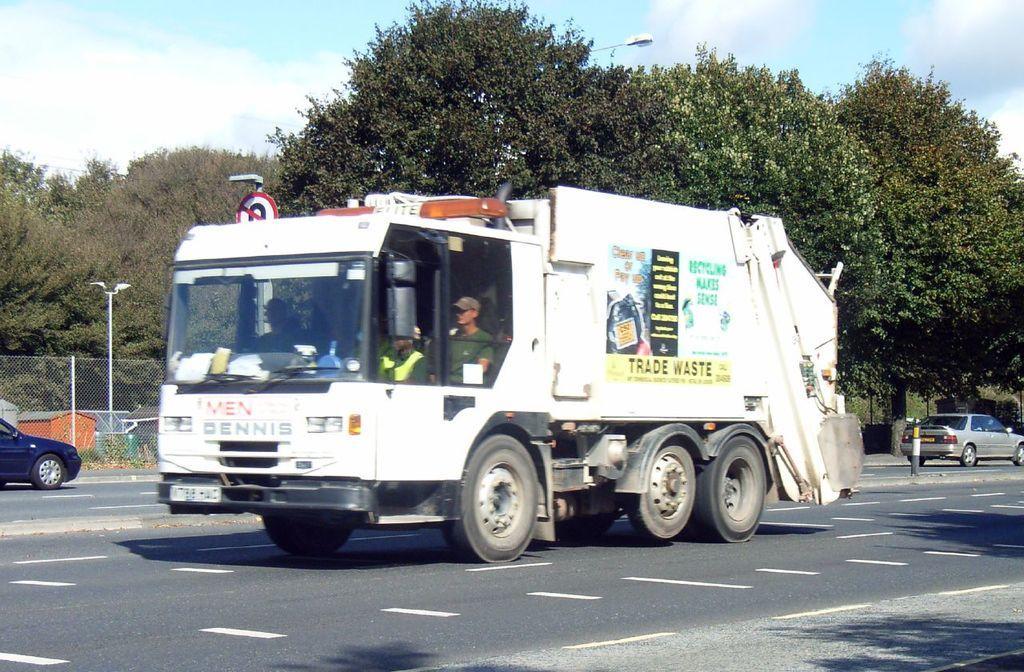Can you describe this image briefly? Vehicles are on the road. In this vehicle we can see people. Background there are light poles, mesh, houses, trees and cloudy sky. 